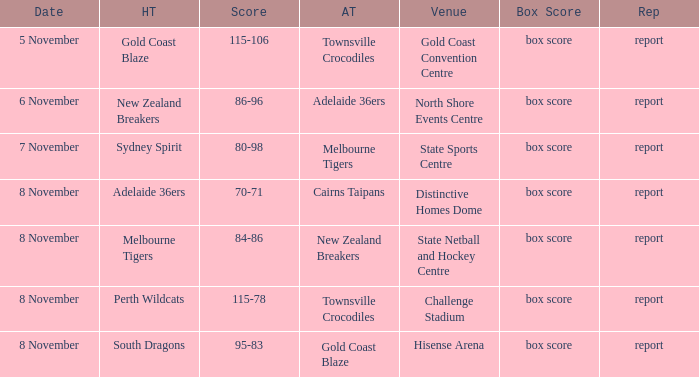What was the box score during a home game of the Adelaide 36ers? Box score. 